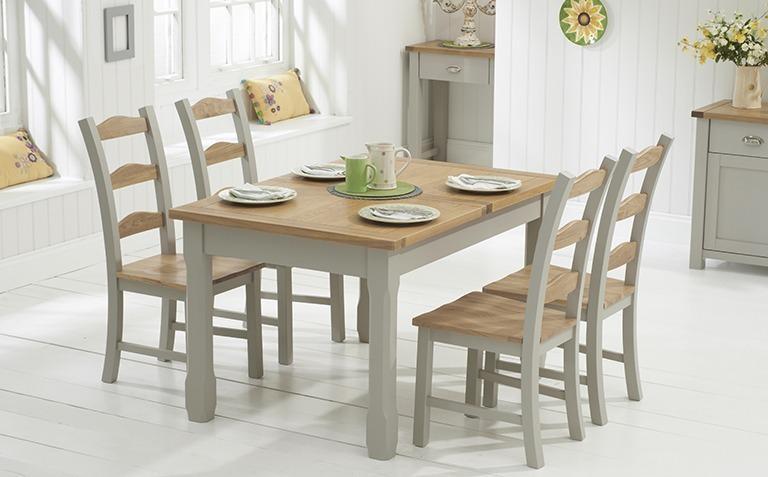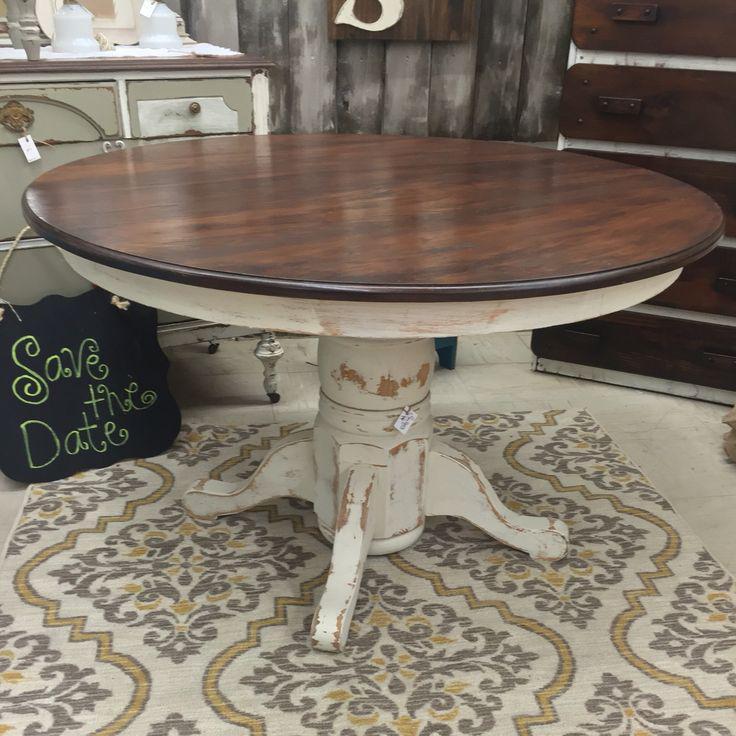The first image is the image on the left, the second image is the image on the right. Evaluate the accuracy of this statement regarding the images: "One image shows white chairs around a round pedestal table, and the other shows white chairs around an oblong pedestal table.". Is it true? Answer yes or no. No. The first image is the image on the left, the second image is the image on the right. For the images shown, is this caption "A dining table in one image is round with four chairs, while a table in the second image is elongated and has six chairs." true? Answer yes or no. No. 